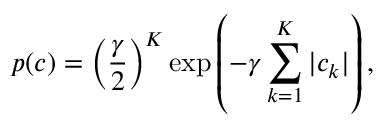<formula> <loc_0><loc_0><loc_500><loc_500>p ( { c } ) = \left ( \frac { \gamma } { 2 } \right ) ^ { K } \exp \left ( - \gamma \sum _ { k = 1 } ^ { K } | c _ { k } | \right ) ,</formula> 